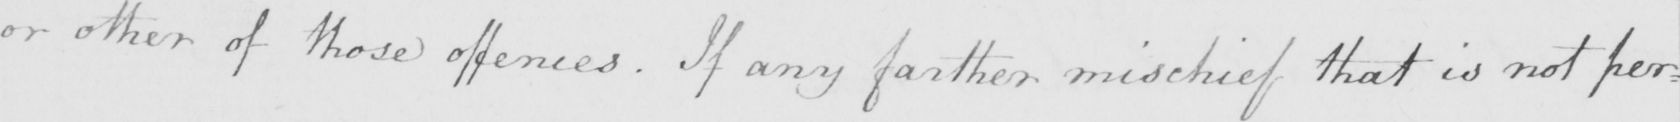Please provide the text content of this handwritten line. or other of these offences . If any farther mischief that is not per : 